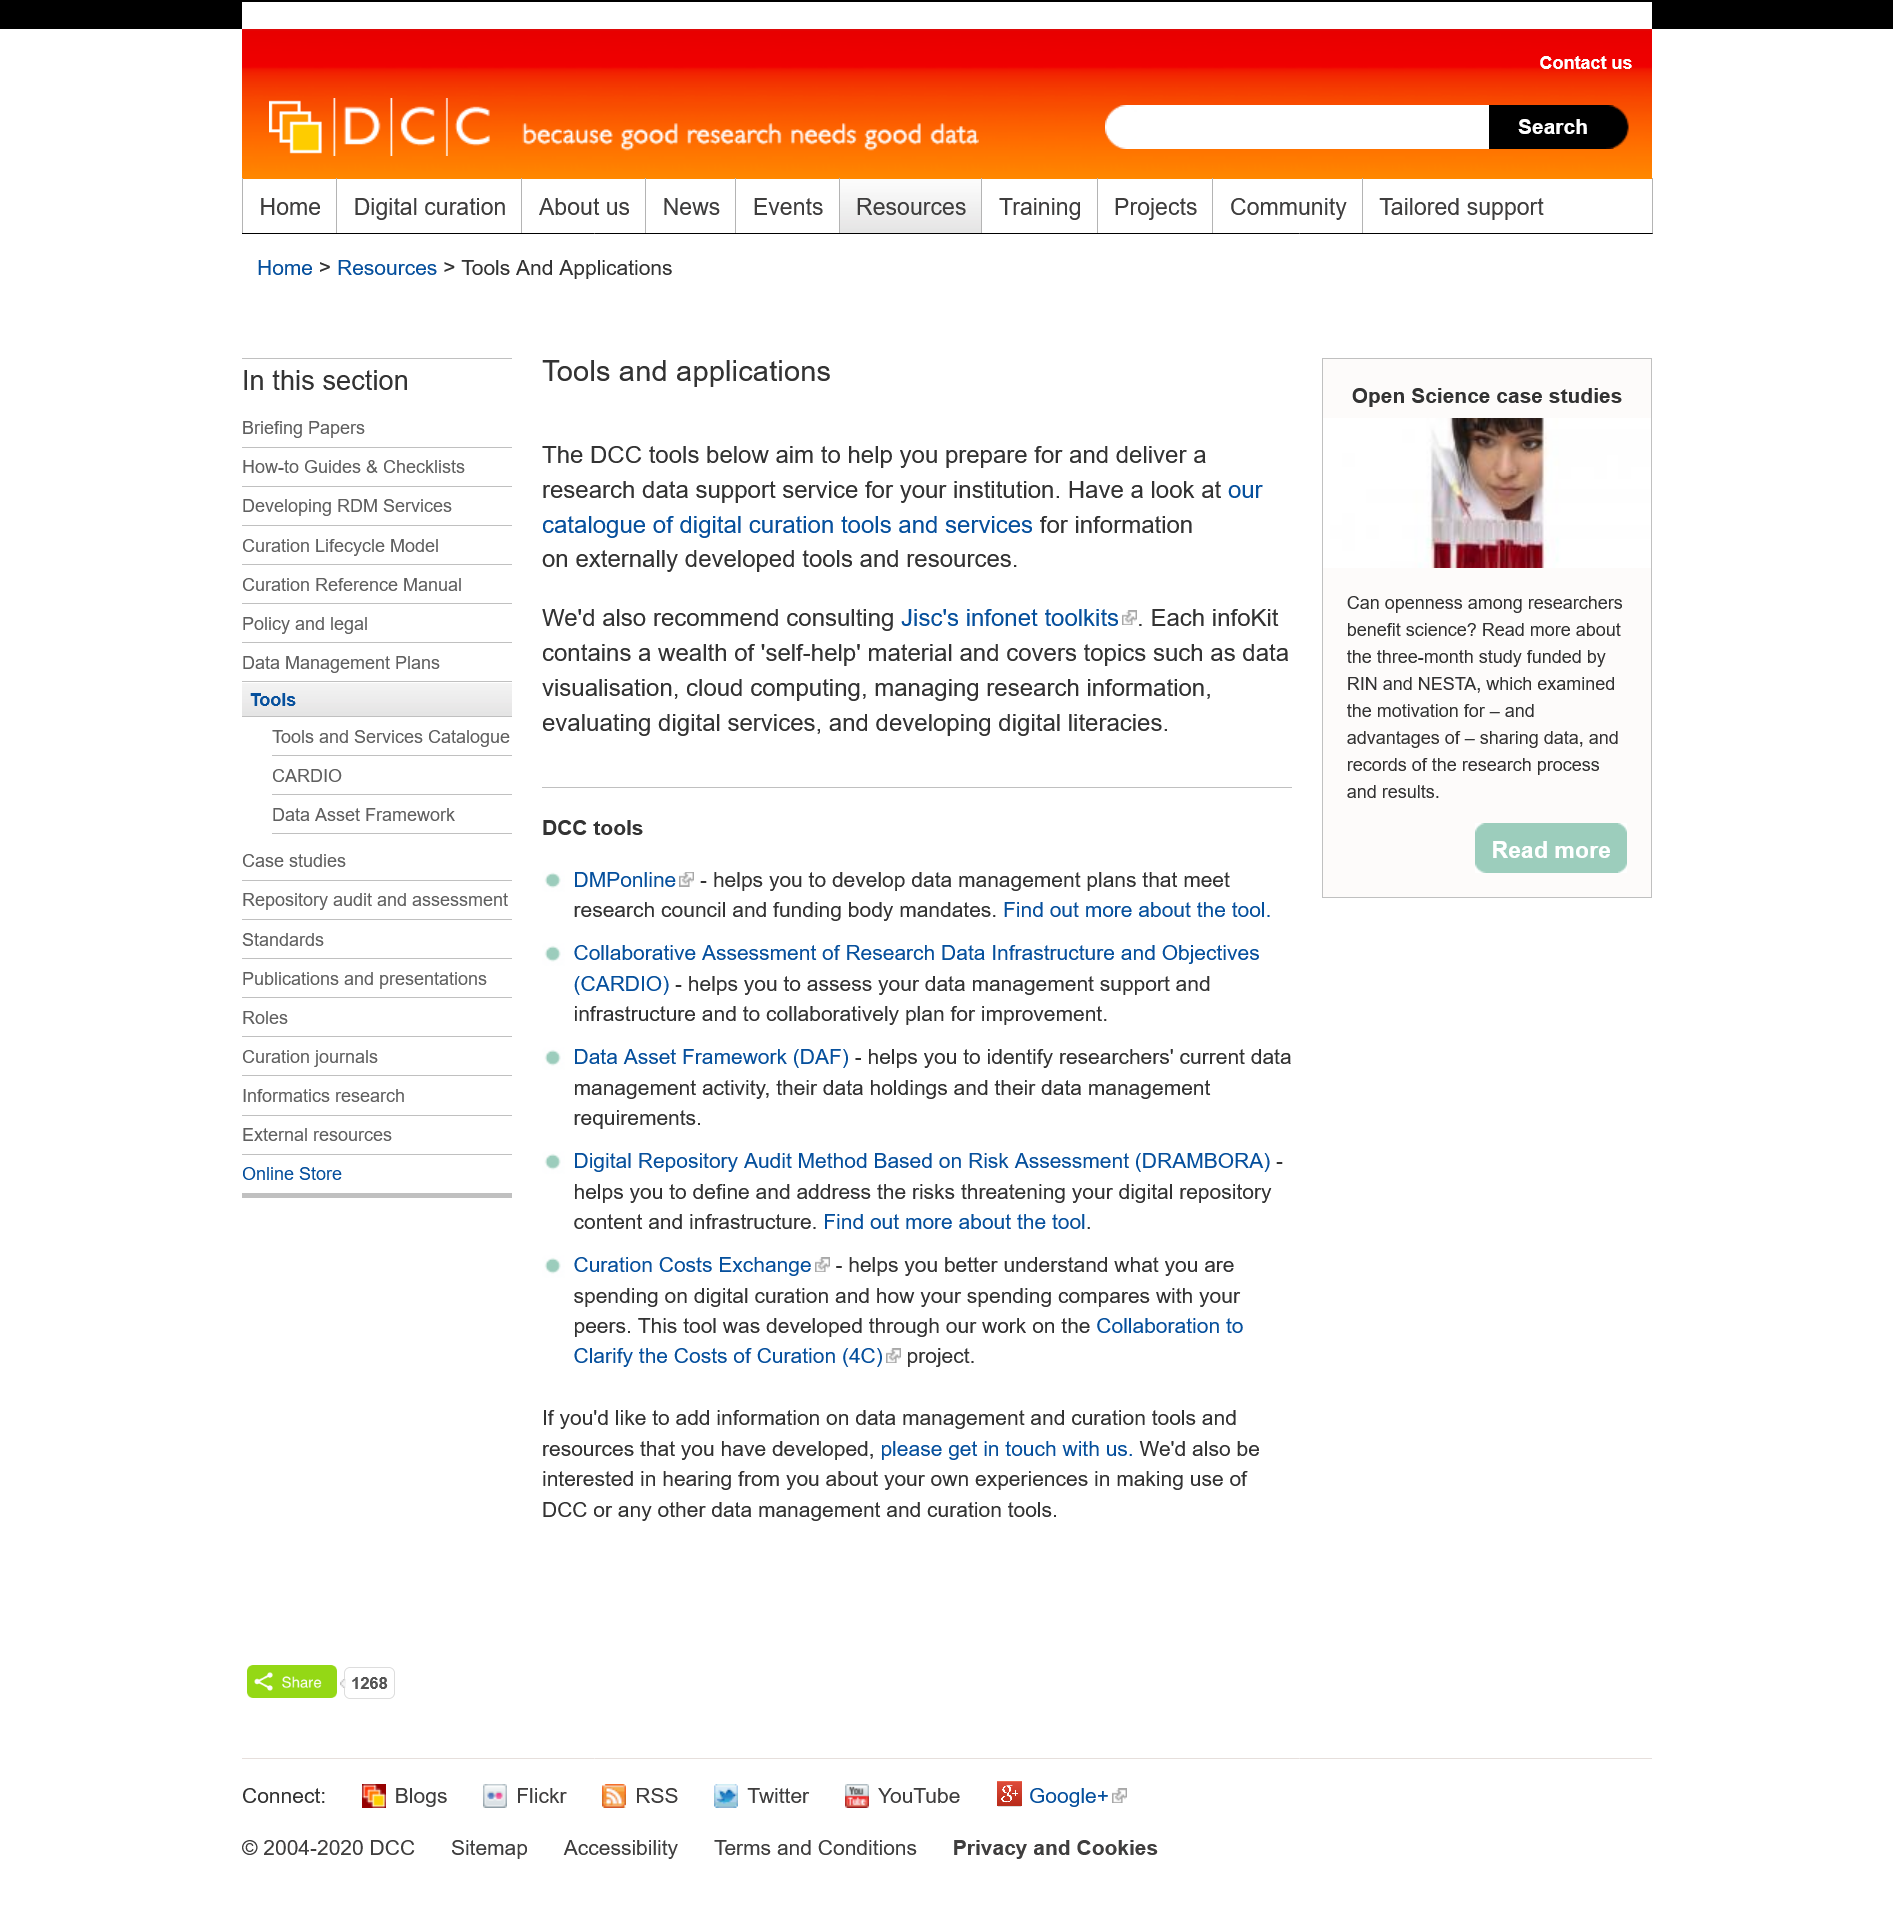List a handful of essential elements in this visual. The purpose of DCC tools is to assist in preparing and delivering research data support services for institutions. Yes, topic cloud computing is covered by infoKits. It is recommended to use Jisc's infonet toolkits for the most suitable toolkit. 